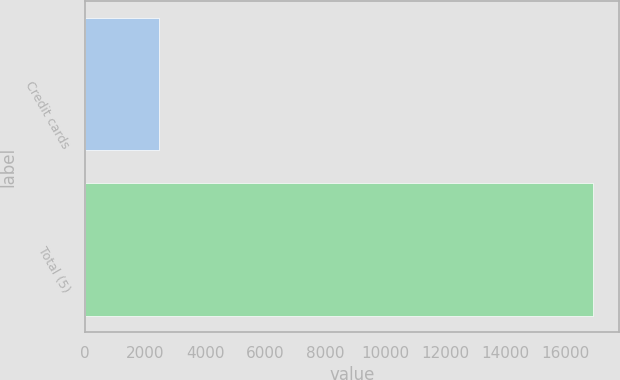Convert chart to OTSL. <chart><loc_0><loc_0><loc_500><loc_500><bar_chart><fcel>Credit cards<fcel>Total (5)<nl><fcel>2453<fcel>16935<nl></chart> 